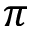<formula> <loc_0><loc_0><loc_500><loc_500>\pi</formula> 